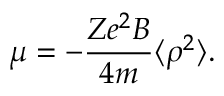<formula> <loc_0><loc_0><loc_500><loc_500>\mu = - { \frac { Z e ^ { 2 } B } { 4 m } } \langle \rho ^ { 2 } \rangle .</formula> 